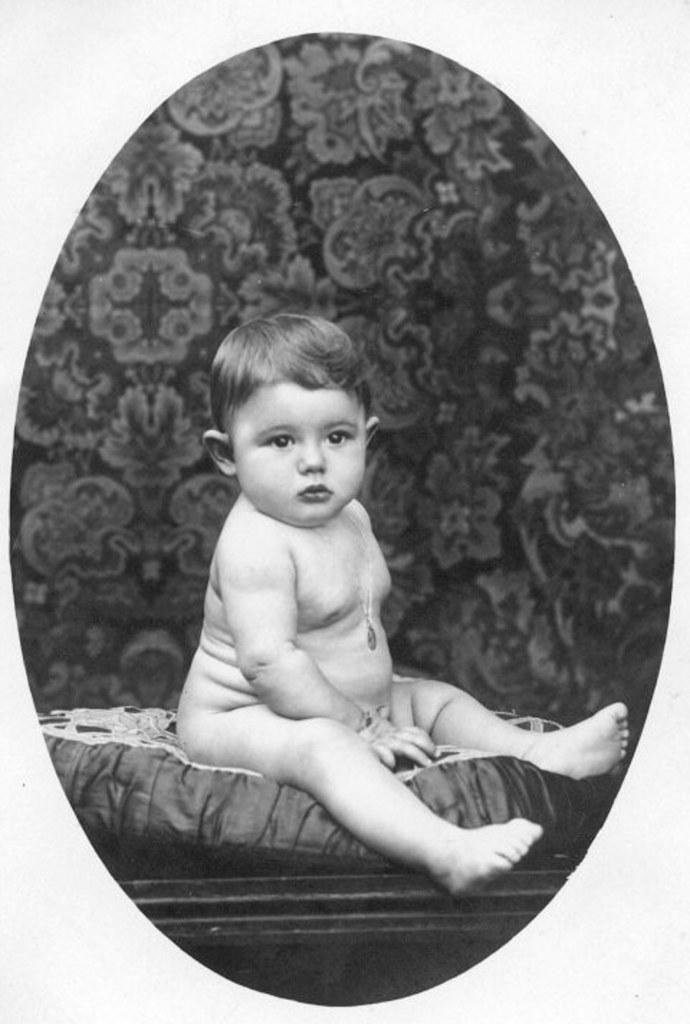In one or two sentences, can you explain what this image depicts? In this black and white image there is a small baby in the foreground. 